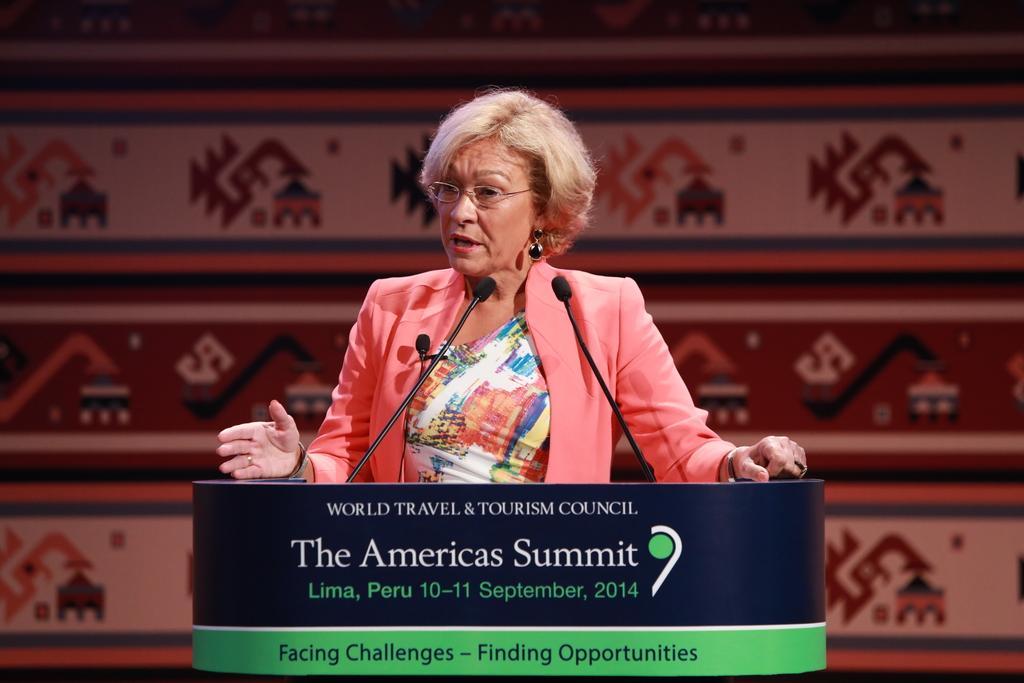How would you summarize this image in a sentence or two? In this picture we can see a woman wore spectacle and standing at a podium and speaking on mics. 